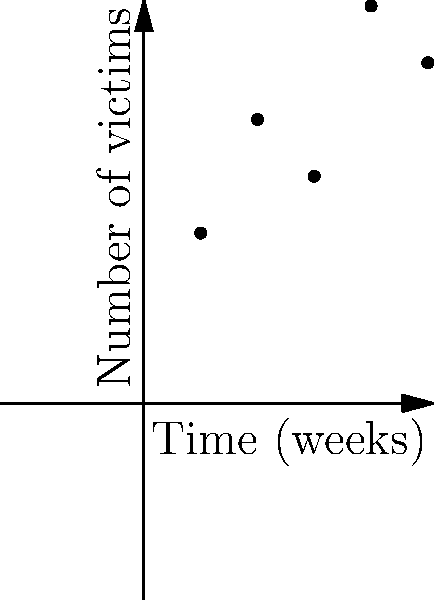A serial killer has been active for 5 weeks, with the number of victims each week shown in the graph. Based on the trend line, what is the probability that the killer will claim more than 8 victims in week 6, assuming the number of victims follows a Poisson distribution with a mean equal to the predicted value from the trend line? Let's approach this step-by-step:

1) First, we need to find the equation of the trend line. From the graph, we can see it's a linear trend.

2) The trend line equation is of the form $y = mx + b$, where $m$ is the slope and $b$ is the y-intercept.

3) From the graph, we can estimate that when $x = 0$, $y \approx 2.5$, and when $x = 6$, $y \approx 7.5$.

4) Using these points, we can calculate the slope:
   $m = \frac{7.5 - 2.5}{6 - 0} = \frac{5}{6} \approx 0.833$

5) So our trend line equation is approximately:
   $y = 0.833x + 2.5$

6) For week 6, $x = 6$, so the predicted number of victims is:
   $y = 0.833(6) + 2.5 = 7.5$

7) Now, assuming a Poisson distribution with mean $\lambda = 7.5$, we need to find $P(X > 8)$, where $X$ is the number of victims.

8) This is equivalent to $1 - P(X \leq 8)$

9) Using the cumulative distribution function of the Poisson distribution:
   $P(X \leq 8) = e^{-\lambda} \sum_{k=0}^{8} \frac{\lambda^k}{k!}$

10) Calculating this (usually with a calculator or computer):
    $P(X \leq 8) \approx 0.6734$

11) Therefore, $P(X > 8) = 1 - 0.6734 = 0.3266$
Answer: 0.3266 or approximately 32.66% 